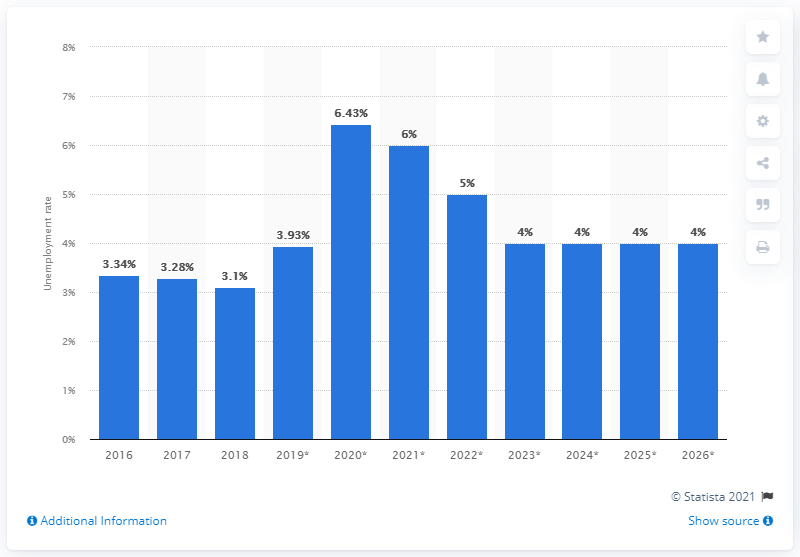Indicate a few pertinent items in this graphic. In 2018, the unemployment rate in Iceland was 3.1%. 